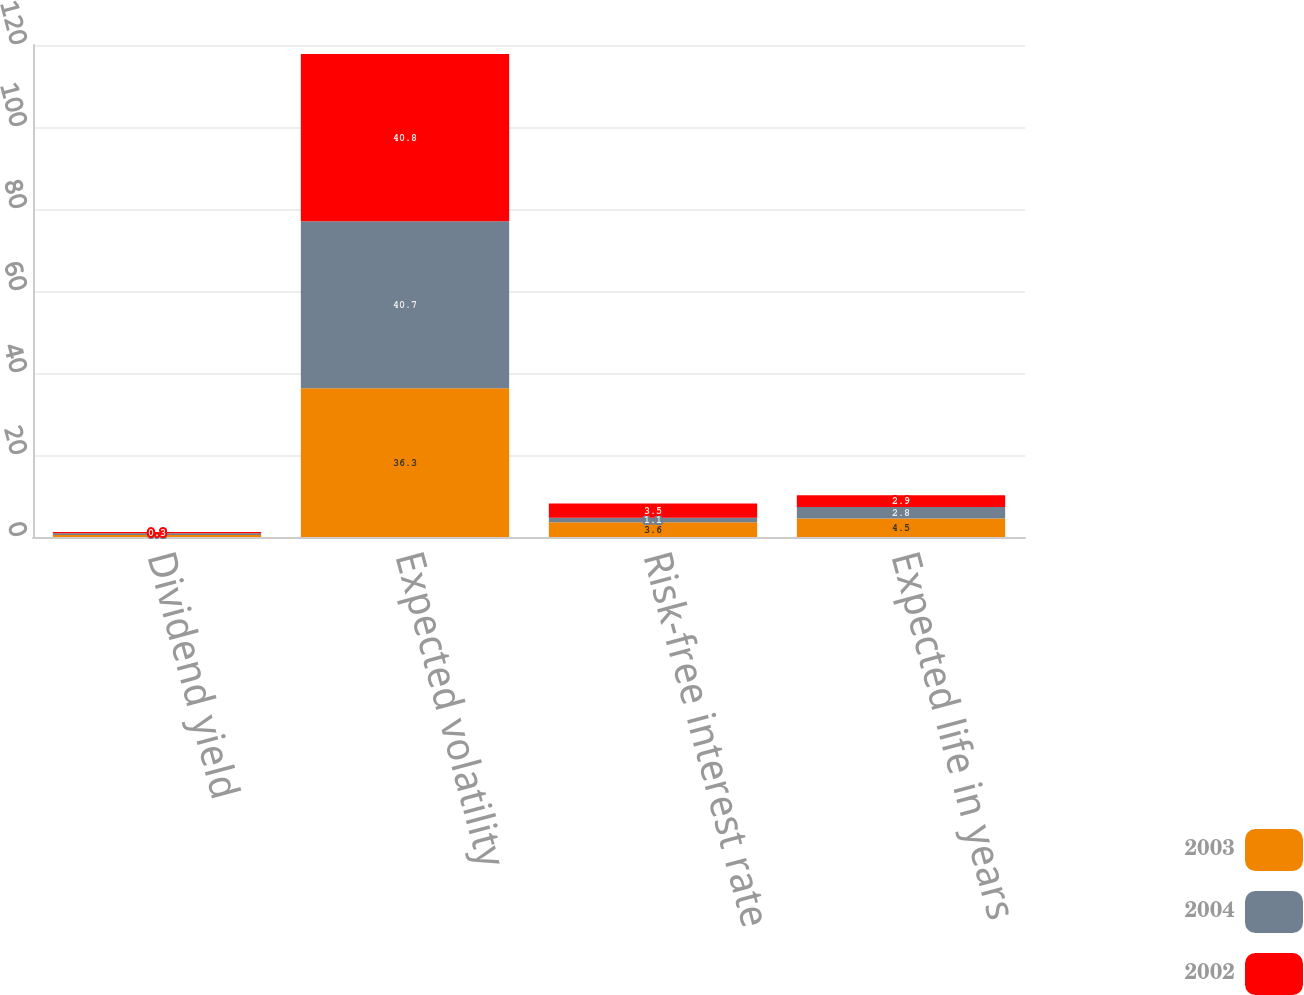Convert chart to OTSL. <chart><loc_0><loc_0><loc_500><loc_500><stacked_bar_chart><ecel><fcel>Dividend yield<fcel>Expected volatility<fcel>Risk-free interest rate<fcel>Expected life in years<nl><fcel>2003<fcel>0.5<fcel>36.3<fcel>3.6<fcel>4.5<nl><fcel>2004<fcel>0.4<fcel>40.7<fcel>1.1<fcel>2.8<nl><fcel>2002<fcel>0.3<fcel>40.8<fcel>3.5<fcel>2.9<nl></chart> 